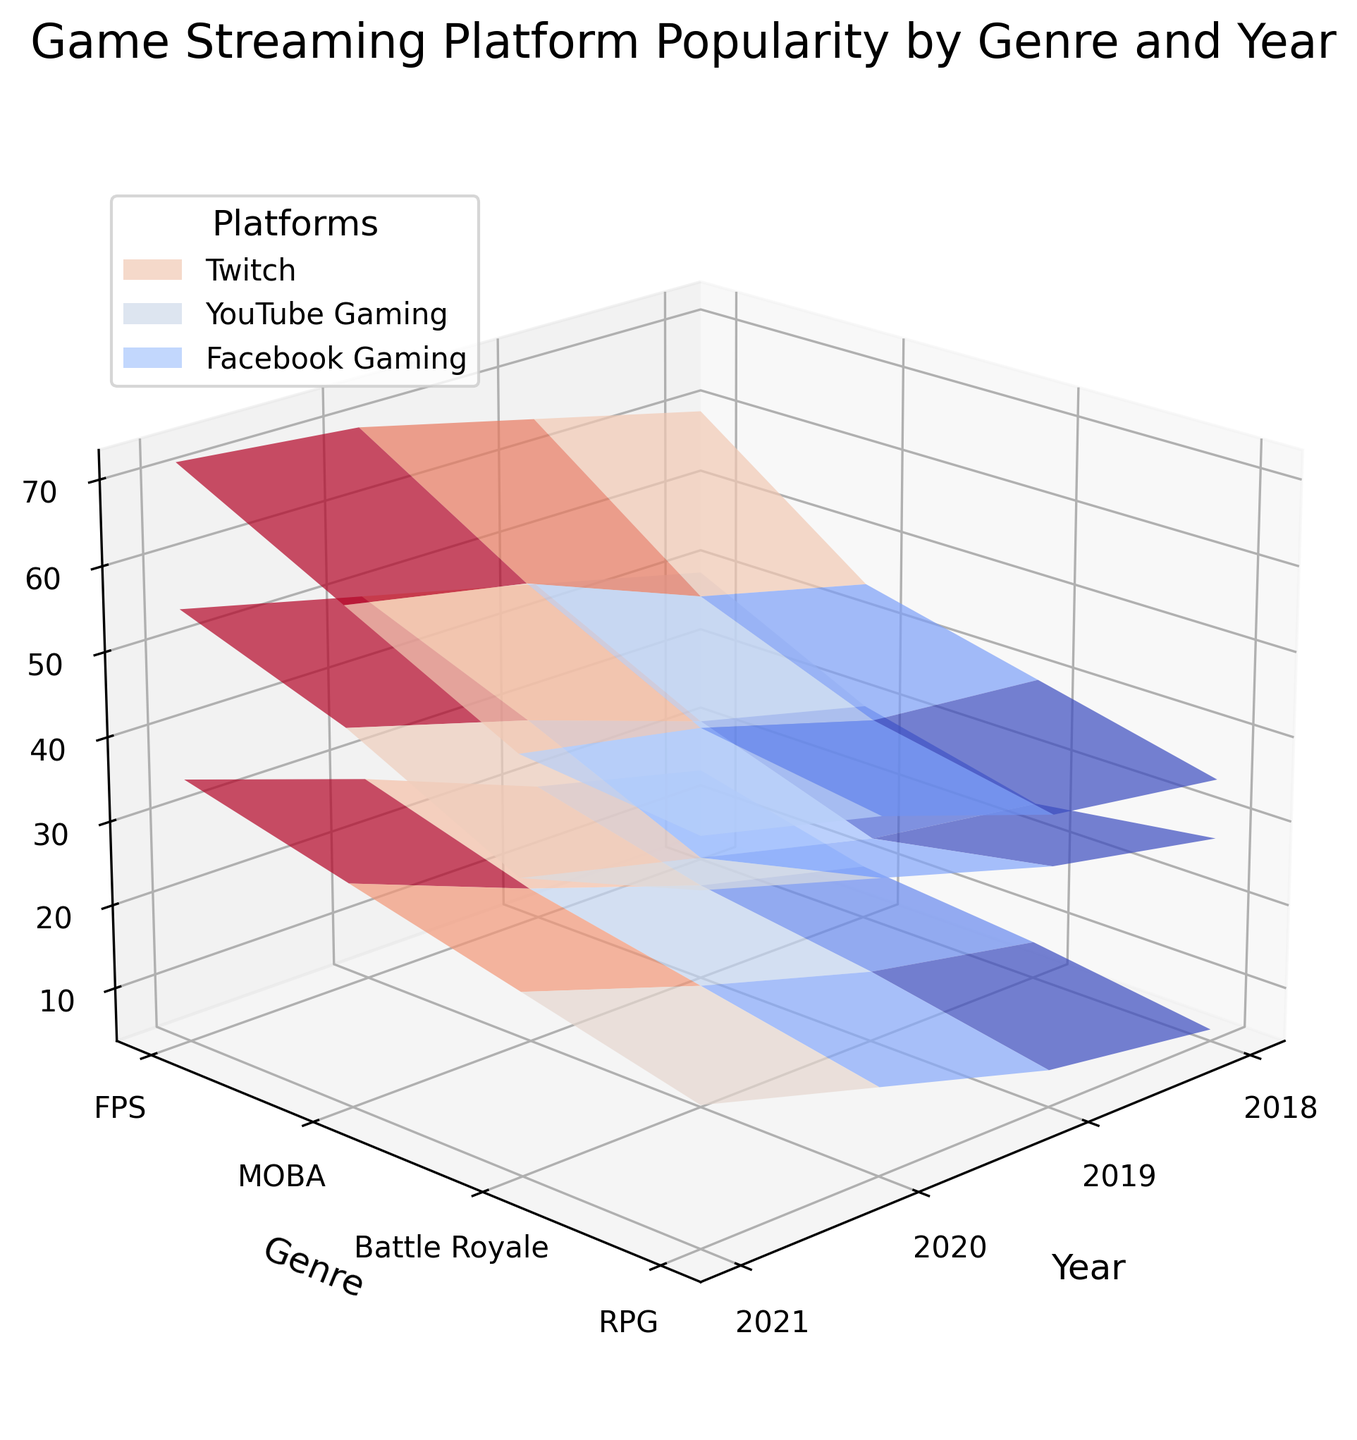What is the range of years displayed on the plot? The x-axis of the plot has labels which show the range of years. From the ticks, we can see the labeled years.
Answer: 2018 to 2021 Which game genre appears to have the highest popularity on Twitch in 2021? In 2021, looking at the different game genres on the third surface plot from the left, Battle Royale has the highest peak.
Answer: Battle Royale What is the difference in popularity of RPG games on YouTube Gaming between 2018 and 2021? Look at the second surface plot from the left for both 2018 and 2021, then find the z-values for RPG in those years and calculate the difference: 44 - 28.
Answer: 16 Which platform shows the most significant increase in FPS game popularity from 2018 to 2021? Compare the z-values for FPS games between 2018 and 2021 on each platform. Twitch shows the largest increase from 45 to 62.
Answer: Twitch Across all platforms, which year exhibits the highest overall popularity for MOBA games? Look at all three surface plots and check the highest z-value for MOBA genre across each year. The highest is in 2021.
Answer: 2021 For Battle Royale games, what is the average popularity on Facebook Gaming over the years shown in the plot? Extract Facebook Gaming z-values for Battle Royale genre across the years: (15 + 20 + 28 + 35) / 4.
Answer: 24.5 Which genre showed the smallest popularity increase on YouTube Gaming from 2019 to 2020? Compare the changes in z-values for each genre on the YouTube Gaming surface plot from 2019 to 2020. RPG has the smallest increase from 32 to 38.
Answer: RPG How does the popularity of MOBA games on Twitch in 2019 compare with the popularity of RPG games on the same platform in 2020? Find z-values for MOBA in 2019 and RPG in 2020 on the Twitch surface plot. MOBA in 2019 is 42 and RPG in 2020 is 45.
Answer: RPG in 2020 is more popular What is the trend in the popularity of FPS games on Twitch from 2018 to 2021? Look at the z-values in the Twitch surface plot for FPS games across the years 2018, 2019, 2020, and 2021. Values are increasing year by year.
Answer: Increasing 